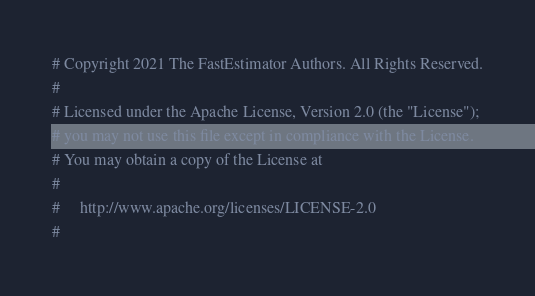<code> <loc_0><loc_0><loc_500><loc_500><_Python_># Copyright 2021 The FastEstimator Authors. All Rights Reserved.
#
# Licensed under the Apache License, Version 2.0 (the "License");
# you may not use this file except in compliance with the License.
# You may obtain a copy of the License at
#
#     http://www.apache.org/licenses/LICENSE-2.0
#</code> 